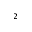<formula> <loc_0><loc_0><loc_500><loc_500>^ { 2 }</formula> 